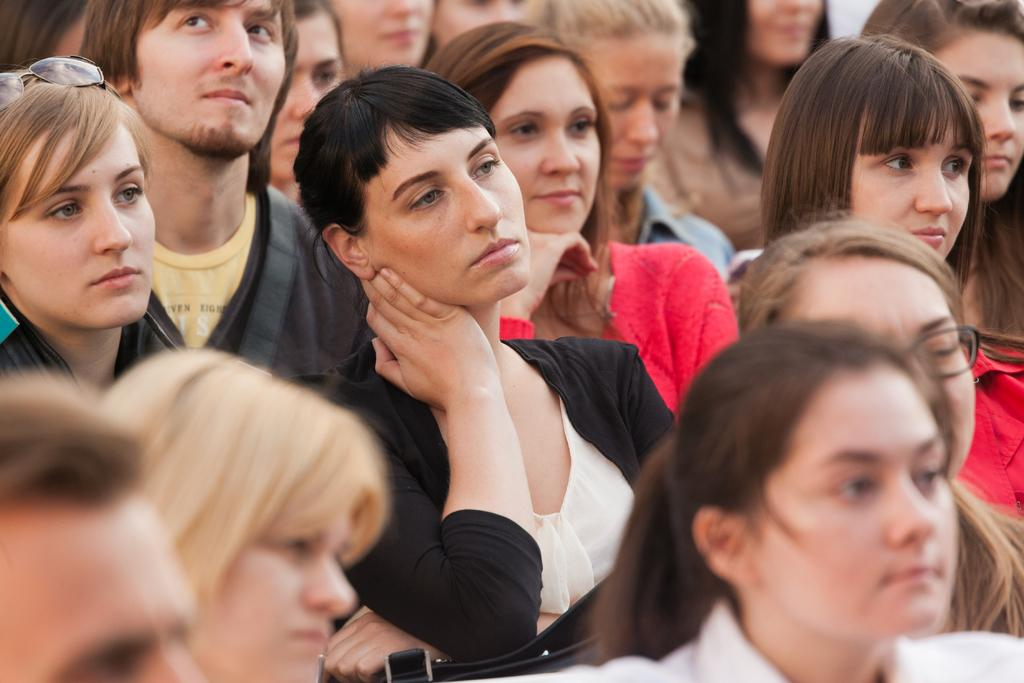What is the main subject of the image? There is a beautiful woman sitting in the middle of the image. What is the woman wearing? The woman is wearing a black dress. Are there any other people in the image? Yes, there are other women sitting in the image. What are the other women doing? The other women are observing to the right side. What reason did the woman give for sitting in the middle of the image? The image does not provide any information about the woman's reason for sitting in the middle. --- 